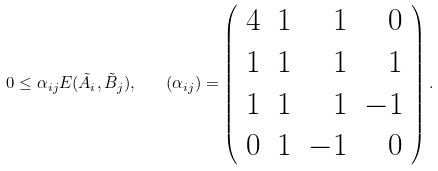<formula> <loc_0><loc_0><loc_500><loc_500>0 \leq \alpha _ { i j } E ( \tilde { A } _ { i } , \tilde { B } _ { j } ) , \quad ( \alpha _ { i j } ) = \left ( \begin{array} { r r r r } 4 & 1 & 1 & 0 \\ 1 & 1 & 1 & 1 \\ 1 & 1 & 1 & - 1 \\ 0 & 1 & - 1 & 0 \end{array} \right ) .</formula> 